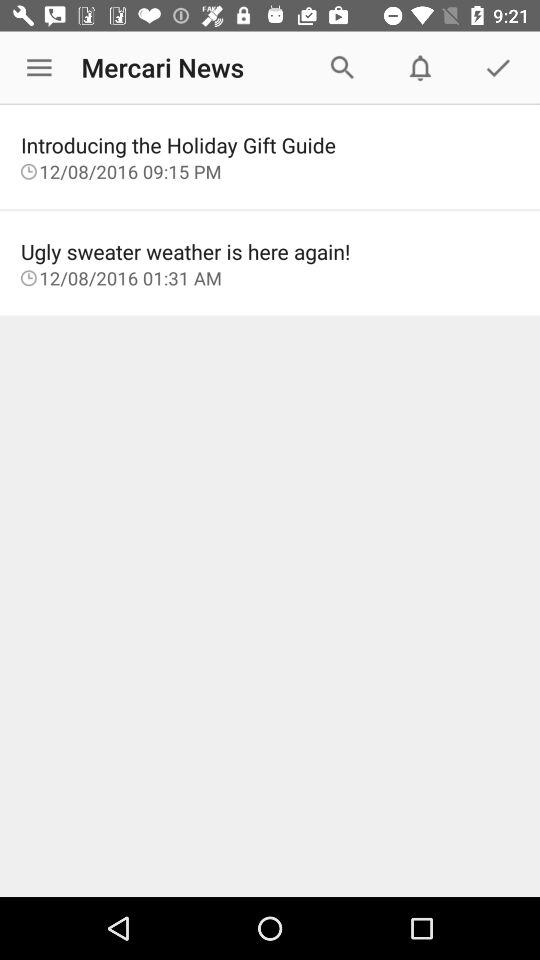On what date is "Ugly sweater weather is here again" posted? The date is 12/08/2016. 